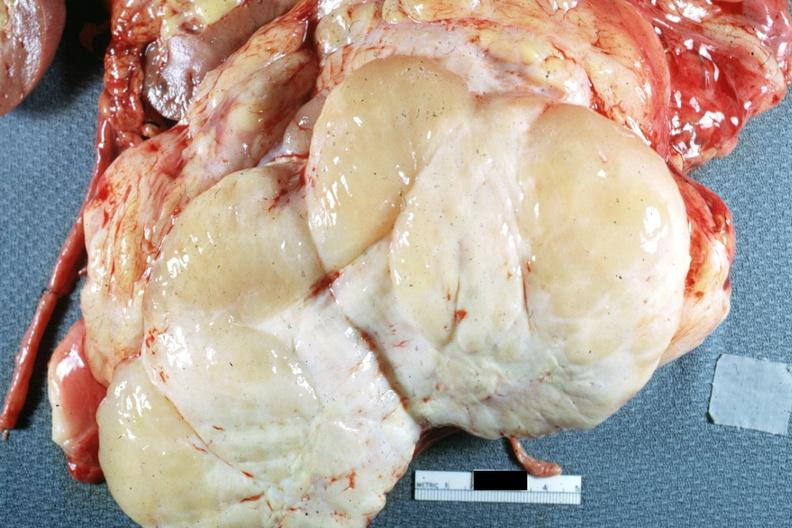s peritoneum present?
Answer the question using a single word or phrase. Yes 